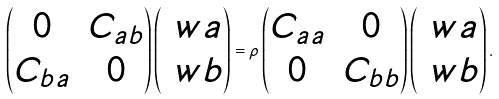<formula> <loc_0><loc_0><loc_500><loc_500>\begin{pmatrix} 0 & C _ { a b } \\ C _ { b a } & 0 \end{pmatrix} \begin{pmatrix} \ w a \\ \ w b \end{pmatrix} = \rho \begin{pmatrix} C _ { a a } & 0 \\ 0 & C _ { b b } \end{pmatrix} \begin{pmatrix} \ w a \\ \ w b \end{pmatrix} .</formula> 